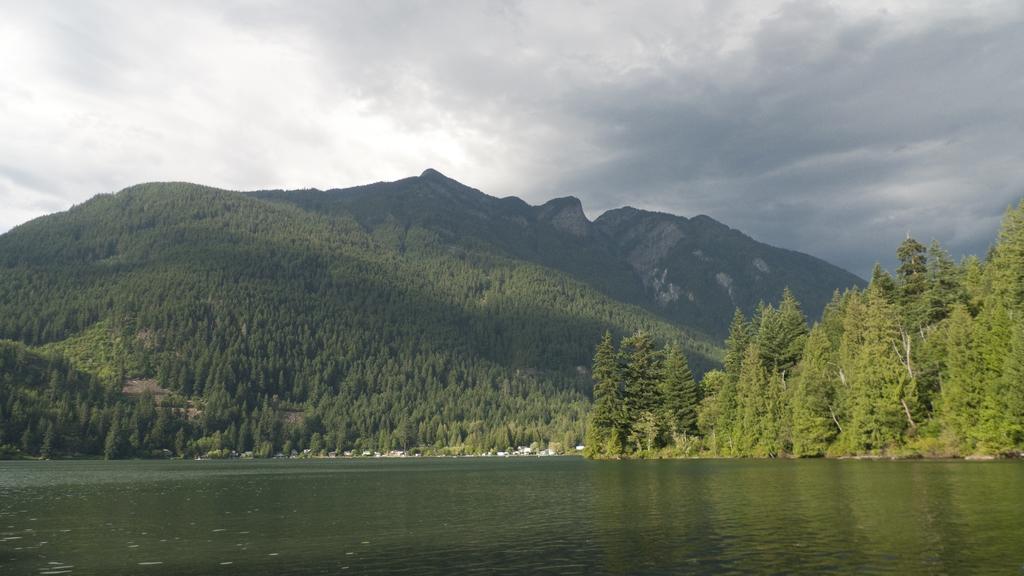Describe this image in one or two sentences. In this picture we can see water. There are reflections of a few trees visible in the water. We can see some trees from left to right. Few mountains are visible in the background. Sky is cloudy. 